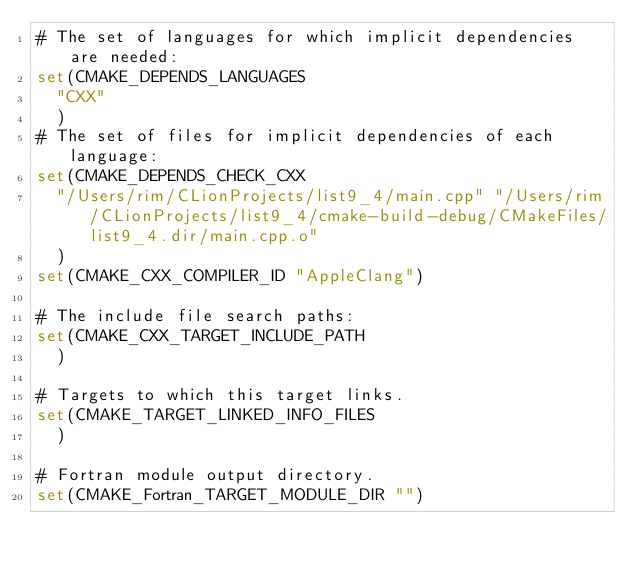<code> <loc_0><loc_0><loc_500><loc_500><_CMake_># The set of languages for which implicit dependencies are needed:
set(CMAKE_DEPENDS_LANGUAGES
  "CXX"
  )
# The set of files for implicit dependencies of each language:
set(CMAKE_DEPENDS_CHECK_CXX
  "/Users/rim/CLionProjects/list9_4/main.cpp" "/Users/rim/CLionProjects/list9_4/cmake-build-debug/CMakeFiles/list9_4.dir/main.cpp.o"
  )
set(CMAKE_CXX_COMPILER_ID "AppleClang")

# The include file search paths:
set(CMAKE_CXX_TARGET_INCLUDE_PATH
  )

# Targets to which this target links.
set(CMAKE_TARGET_LINKED_INFO_FILES
  )

# Fortran module output directory.
set(CMAKE_Fortran_TARGET_MODULE_DIR "")
</code> 